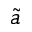<formula> <loc_0><loc_0><loc_500><loc_500>\tilde { a }</formula> 